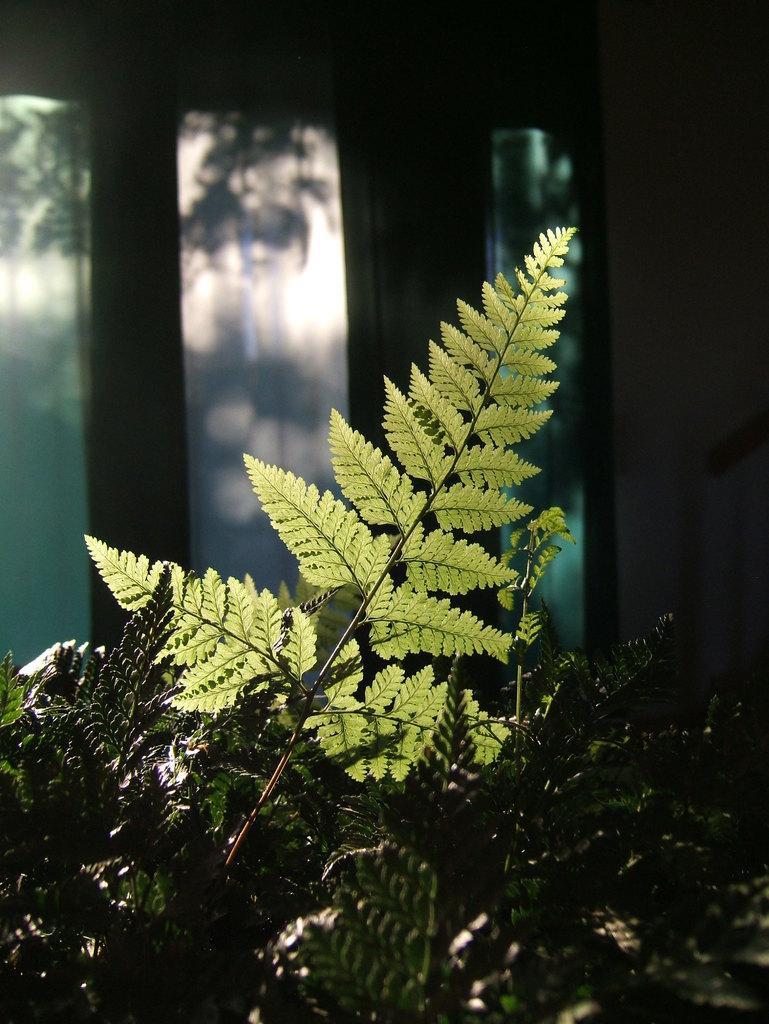Could you give a brief overview of what you see in this image? At the bottom I can see plants. In the background I can see a window and trees. This image is taken in a room. 